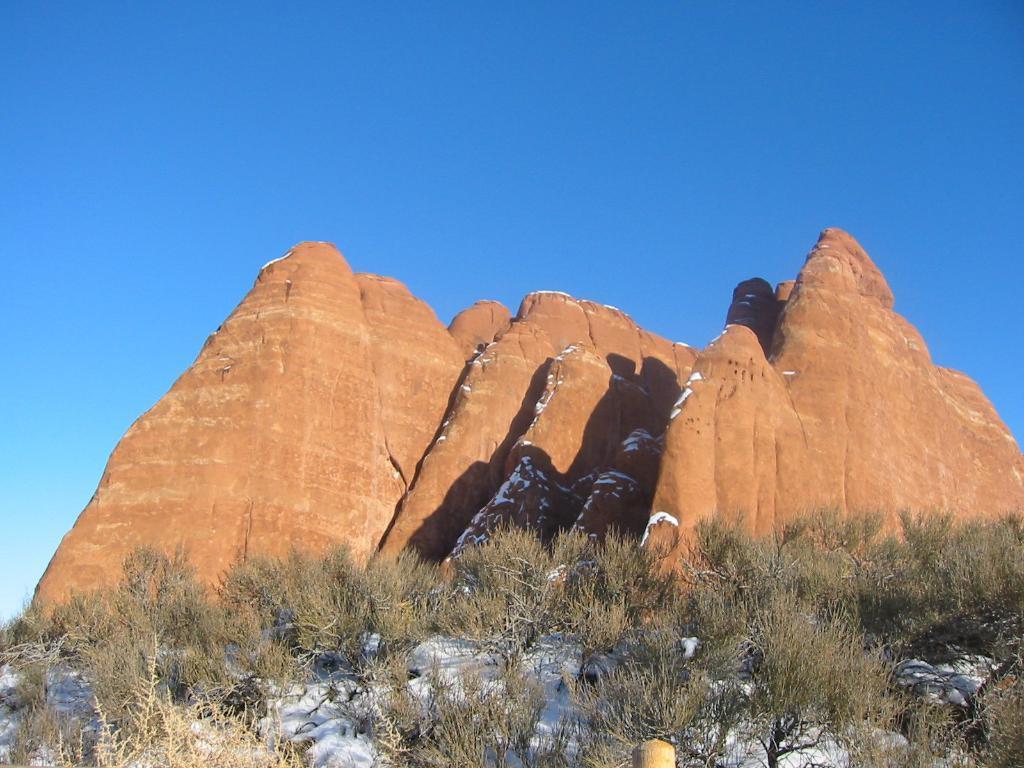Can you describe this image briefly? In the image there are some plants in the foreground and behind the plants there are hills. 